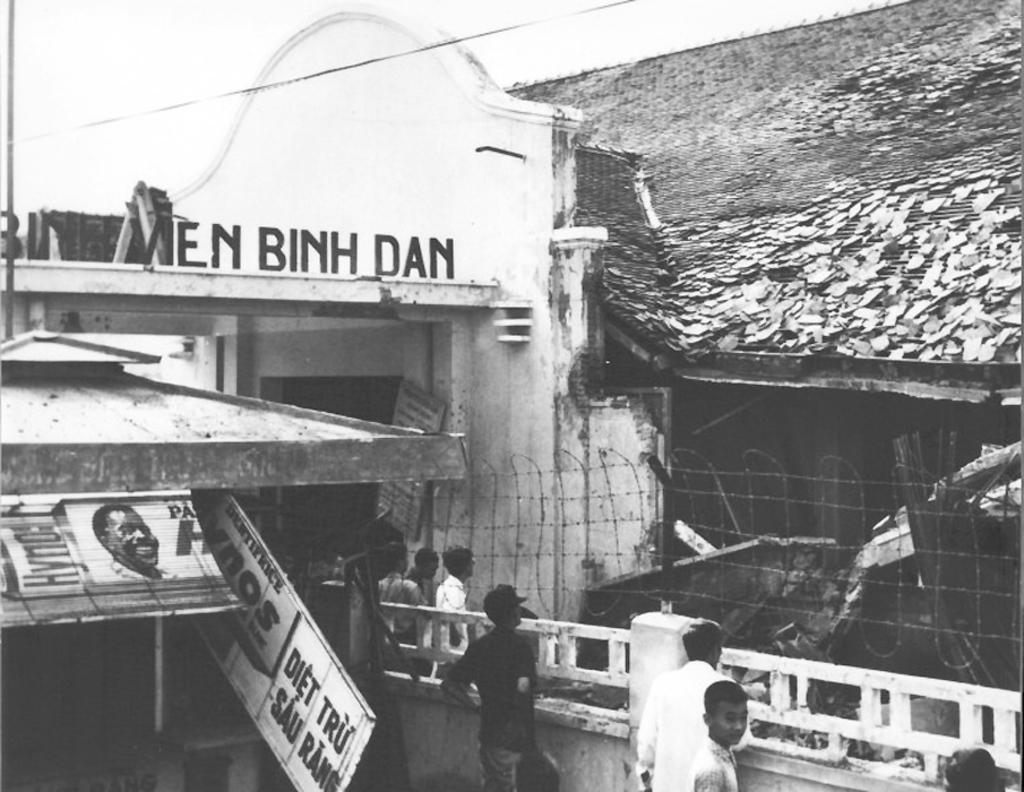Can you describe this image briefly? It is a black and white image. In this image, we can see houses, hoarding, railing, wire fencing, board, some text, walls and few people. On the left side of the image, we can see a pole. Here there is a wire. 